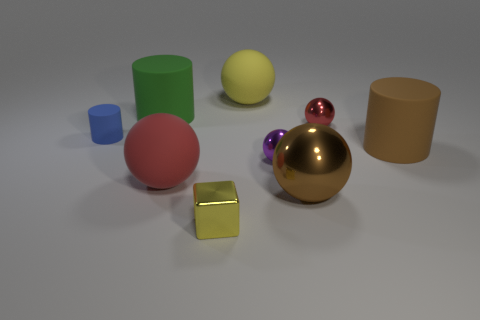Is there anything else that is the same color as the shiny cube?
Offer a very short reply. Yes. What is the shape of the large brown object that is the same material as the purple object?
Make the answer very short. Sphere. Are the large object in front of the large red sphere and the purple sphere made of the same material?
Offer a very short reply. Yes. The thing that is the same color as the metallic block is what shape?
Give a very brief answer. Sphere. There is a tiny object that is in front of the large red matte ball; is its color the same as the large ball that is behind the tiny purple object?
Provide a short and direct response. Yes. What number of objects are both behind the blue rubber cylinder and in front of the big brown matte cylinder?
Offer a terse response. 0. What material is the big yellow thing?
Your answer should be compact. Rubber. There is a red shiny object that is the same size as the blue cylinder; what is its shape?
Make the answer very short. Sphere. Is the red thing right of the brown metal sphere made of the same material as the small thing that is in front of the big metallic object?
Your answer should be compact. Yes. What number of large rubber cylinders are there?
Offer a terse response. 2. 